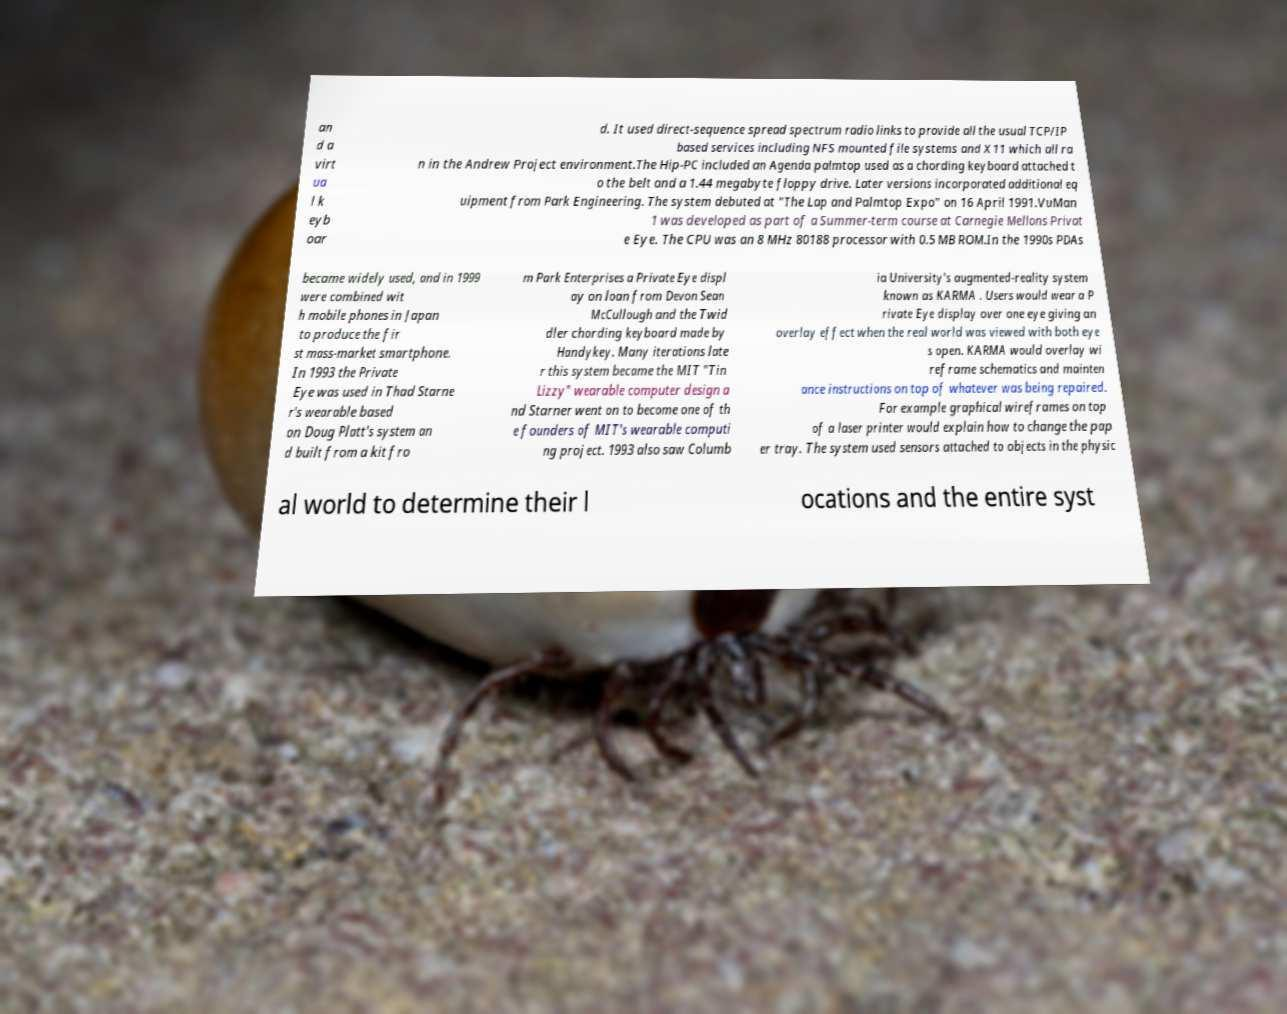Can you read and provide the text displayed in the image?This photo seems to have some interesting text. Can you extract and type it out for me? an d a virt ua l k eyb oar d. It used direct-sequence spread spectrum radio links to provide all the usual TCP/IP based services including NFS mounted file systems and X11 which all ra n in the Andrew Project environment.The Hip-PC included an Agenda palmtop used as a chording keyboard attached t o the belt and a 1.44 megabyte floppy drive. Later versions incorporated additional eq uipment from Park Engineering. The system debuted at "The Lap and Palmtop Expo" on 16 April 1991.VuMan 1 was developed as part of a Summer-term course at Carnegie Mellons Privat e Eye. The CPU was an 8 MHz 80188 processor with 0.5 MB ROM.In the 1990s PDAs became widely used, and in 1999 were combined wit h mobile phones in Japan to produce the fir st mass-market smartphone. In 1993 the Private Eye was used in Thad Starne r's wearable based on Doug Platt's system an d built from a kit fro m Park Enterprises a Private Eye displ ay on loan from Devon Sean McCullough and the Twid dler chording keyboard made by Handykey. Many iterations late r this system became the MIT "Tin Lizzy" wearable computer design a nd Starner went on to become one of th e founders of MIT's wearable computi ng project. 1993 also saw Columb ia University's augmented-reality system known as KARMA . Users would wear a P rivate Eye display over one eye giving an overlay effect when the real world was viewed with both eye s open. KARMA would overlay wi reframe schematics and mainten ance instructions on top of whatever was being repaired. For example graphical wireframes on top of a laser printer would explain how to change the pap er tray. The system used sensors attached to objects in the physic al world to determine their l ocations and the entire syst 